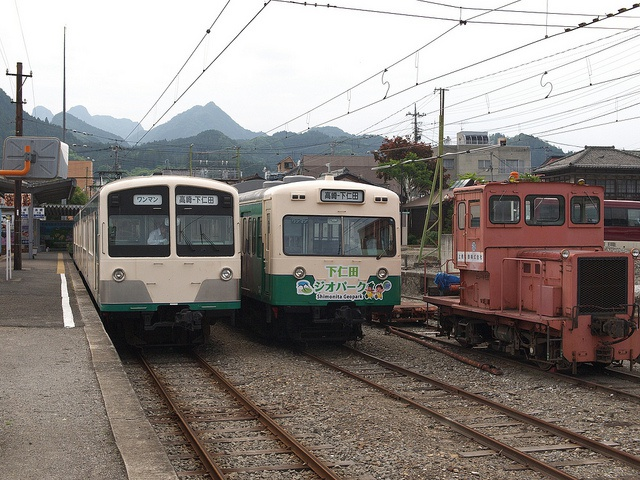Describe the objects in this image and their specific colors. I can see train in white, black, brown, and maroon tones, train in white, black, gray, darkgray, and lightgray tones, train in white, black, gray, darkgray, and tan tones, and people in white and gray tones in this image. 